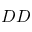Convert formula to latex. <formula><loc_0><loc_0><loc_500><loc_500>D D</formula> 